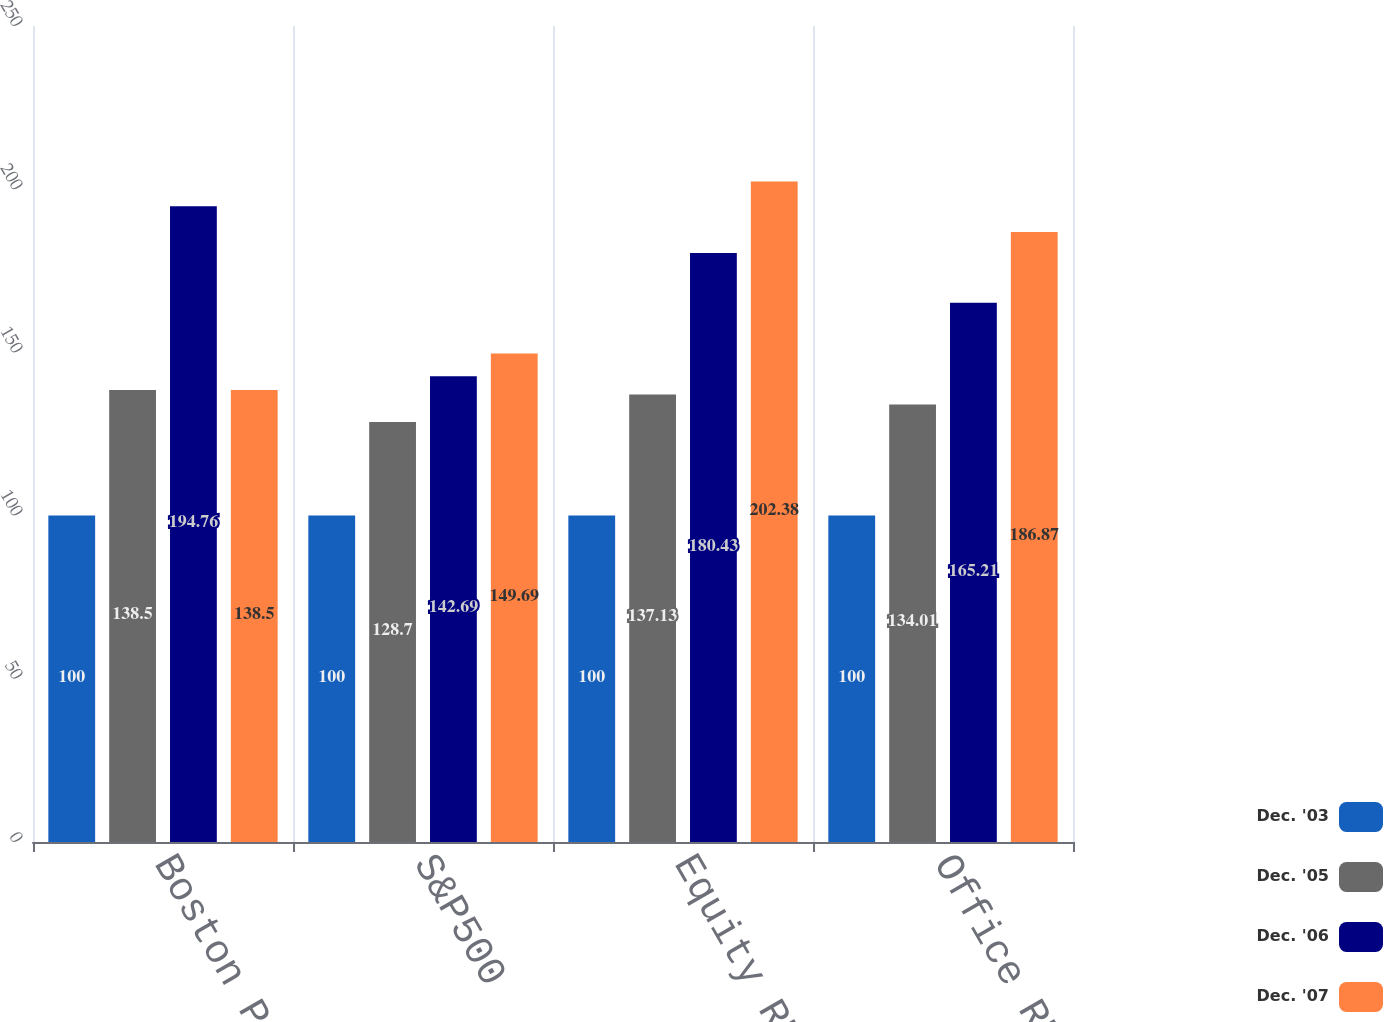Convert chart. <chart><loc_0><loc_0><loc_500><loc_500><stacked_bar_chart><ecel><fcel>Boston Properties<fcel>S&P500<fcel>Equity REIT Index<fcel>Office REIT Index<nl><fcel>Dec. '03<fcel>100<fcel>100<fcel>100<fcel>100<nl><fcel>Dec. '05<fcel>138.5<fcel>128.7<fcel>137.13<fcel>134.01<nl><fcel>Dec. '06<fcel>194.76<fcel>142.69<fcel>180.43<fcel>165.21<nl><fcel>Dec. '07<fcel>138.5<fcel>149.69<fcel>202.38<fcel>186.87<nl></chart> 